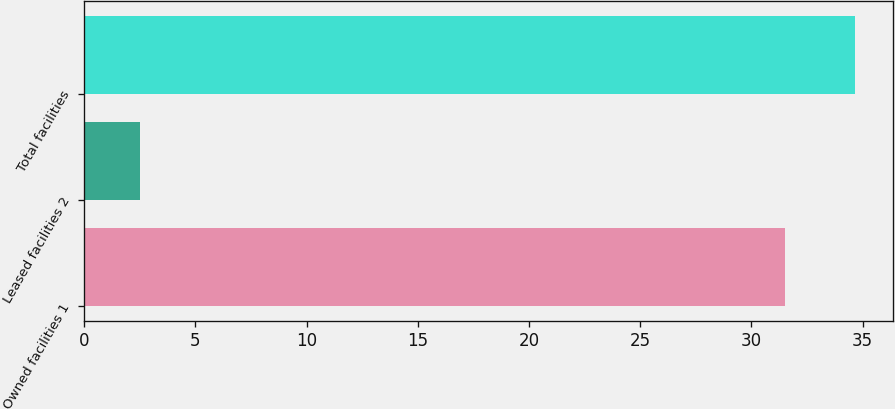Convert chart. <chart><loc_0><loc_0><loc_500><loc_500><bar_chart><fcel>Owned facilities 1<fcel>Leased facilities 2<fcel>Total facilities<nl><fcel>31.5<fcel>2.5<fcel>34.65<nl></chart> 